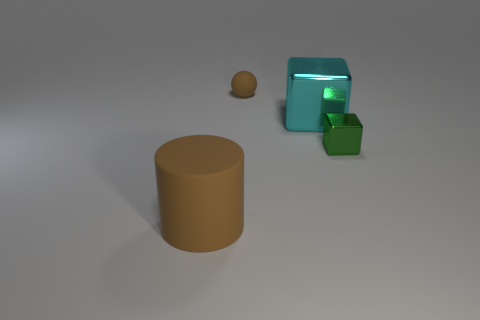What size is the ball that is the same color as the large cylinder?
Your answer should be very brief. Small. The rubber object that is the same color as the ball is what shape?
Make the answer very short. Cylinder. Are there the same number of big brown cylinders on the right side of the tiny cube and big brown objects behind the brown cylinder?
Your answer should be very brief. Yes. What color is the tiny object that is the same shape as the large cyan object?
Your answer should be compact. Green. Are there any other things that have the same color as the large matte thing?
Provide a short and direct response. Yes. How many metallic things are either tiny gray balls or big brown things?
Give a very brief answer. 0. Is the ball the same color as the tiny metal block?
Give a very brief answer. No. Is the number of rubber cylinders to the left of the big cyan shiny block greater than the number of small cyan matte cubes?
Offer a very short reply. Yes. What number of other objects are the same material as the cyan cube?
Provide a short and direct response. 1. How many small objects are cyan cubes or rubber objects?
Ensure brevity in your answer.  1. 